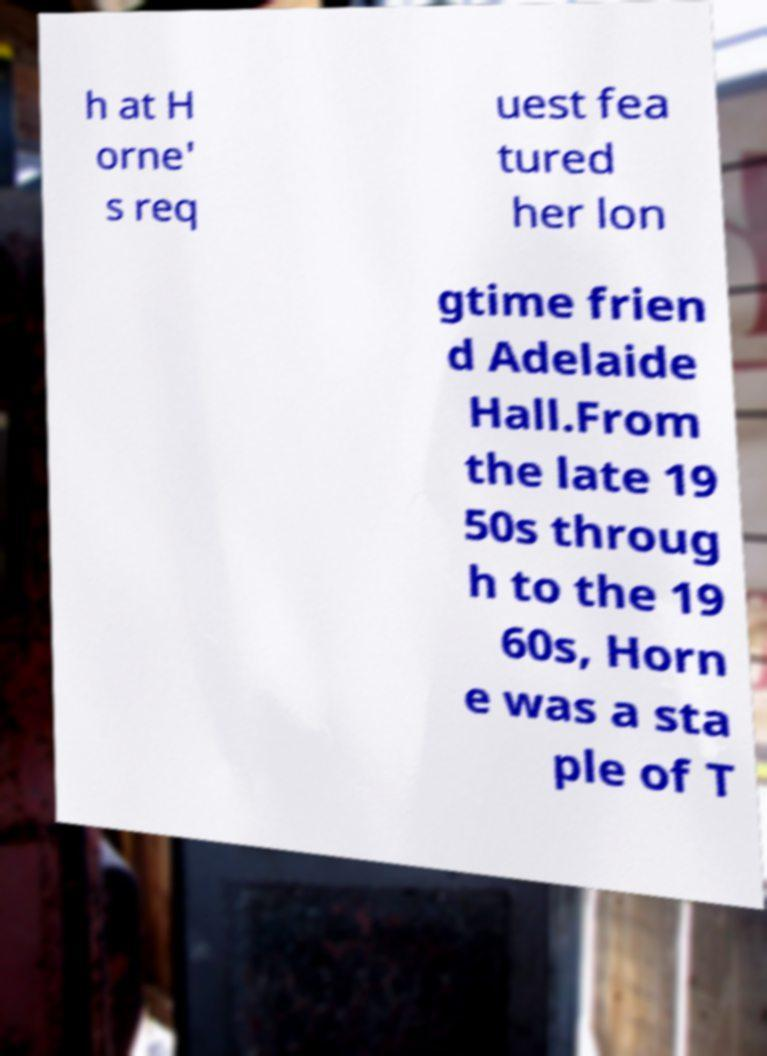Could you extract and type out the text from this image? h at H orne' s req uest fea tured her lon gtime frien d Adelaide Hall.From the late 19 50s throug h to the 19 60s, Horn e was a sta ple of T 